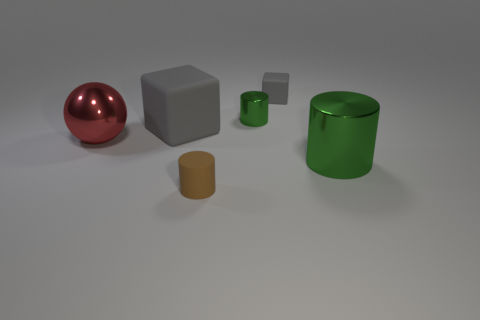How many gray rubber objects have the same size as the brown rubber object?
Provide a succinct answer. 1. What number of metal cylinders are both to the left of the tiny gray object and in front of the large red object?
Provide a short and direct response. 0. There is a metal object in front of the sphere; does it have the same size as the big gray rubber block?
Your answer should be compact. Yes. Are there any objects of the same color as the small cube?
Provide a short and direct response. Yes. The gray thing that is the same material as the small gray block is what size?
Ensure brevity in your answer.  Large. Are there more things in front of the big block than cylinders on the right side of the small gray object?
Your answer should be very brief. Yes. What number of other things are made of the same material as the small gray cube?
Your response must be concise. 2. Do the cylinder behind the metallic sphere and the brown cylinder have the same material?
Your answer should be very brief. No. What is the shape of the small brown matte object?
Offer a very short reply. Cylinder. Is the number of big green metallic objects in front of the small gray matte thing greater than the number of yellow things?
Offer a very short reply. Yes. 